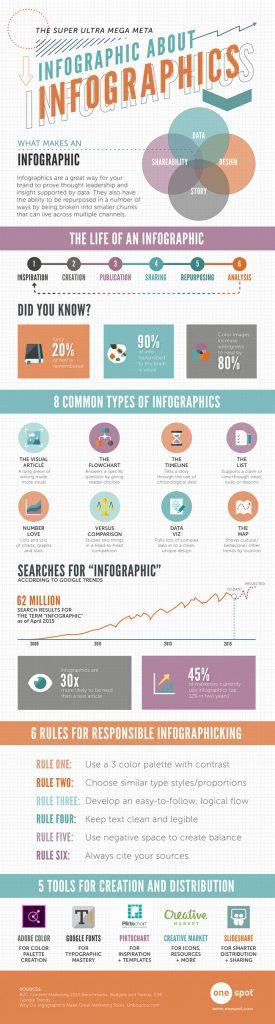Identify some key points in this picture. Of the seven types of infographics listed, Data Viz is the seventh. To create an effective infographic, the third rule is to develop a logical, easy-to-follow flow of information. An infographic is made up of elements other than 'story', such as data, shareability, and design, that contribute to its effectiveness in communicating information. Number Love is the fifth type of infographic listed. The final stage in the creation of an infographic is analysis, which involves evaluating the effectiveness of the infographic in conveying information and achieving its intended purpose. 